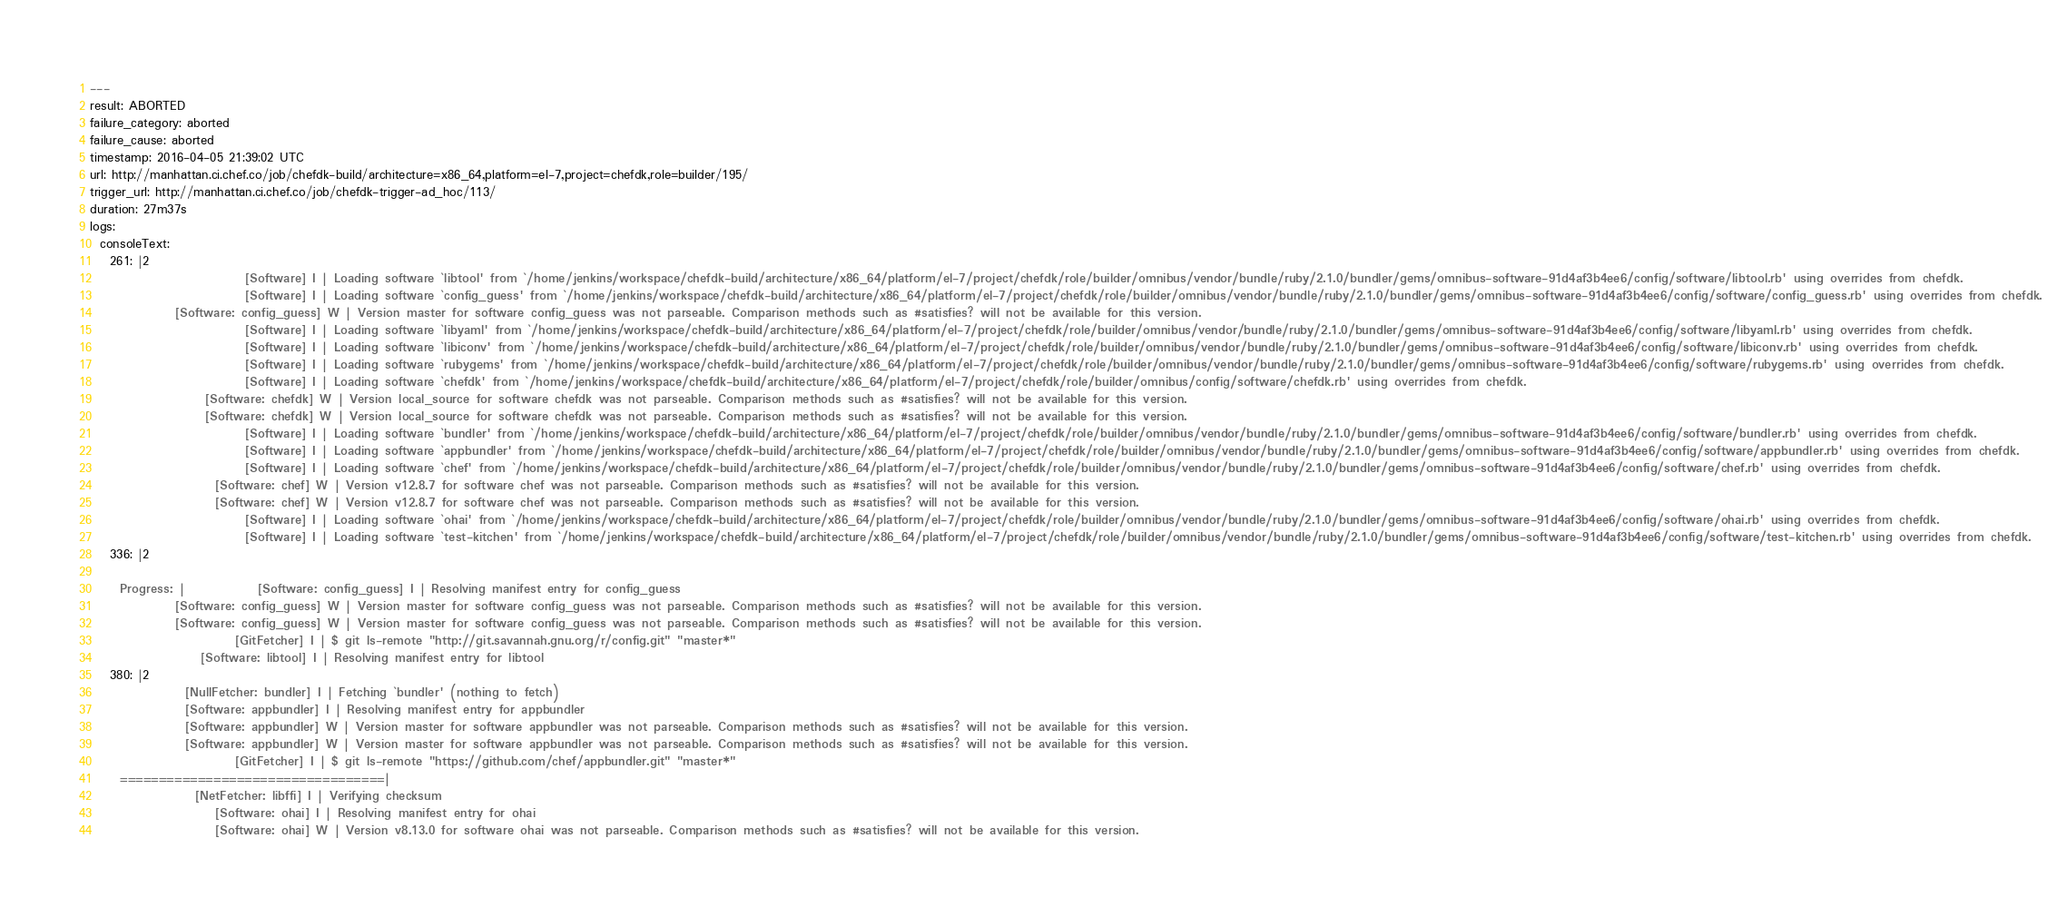<code> <loc_0><loc_0><loc_500><loc_500><_YAML_>---
result: ABORTED
failure_category: aborted
failure_cause: aborted
timestamp: 2016-04-05 21:39:02 UTC
url: http://manhattan.ci.chef.co/job/chefdk-build/architecture=x86_64,platform=el-7,project=chefdk,role=builder/195/
trigger_url: http://manhattan.ci.chef.co/job/chefdk-trigger-ad_hoc/113/
duration: 27m37s
logs:
  consoleText:
    261: |2
                               [Software] I | Loading software `libtool' from `/home/jenkins/workspace/chefdk-build/architecture/x86_64/platform/el-7/project/chefdk/role/builder/omnibus/vendor/bundle/ruby/2.1.0/bundler/gems/omnibus-software-91d4af3b4ee6/config/software/libtool.rb' using overrides from chefdk.
                               [Software] I | Loading software `config_guess' from `/home/jenkins/workspace/chefdk-build/architecture/x86_64/platform/el-7/project/chefdk/role/builder/omnibus/vendor/bundle/ruby/2.1.0/bundler/gems/omnibus-software-91d4af3b4ee6/config/software/config_guess.rb' using overrides from chefdk.
                 [Software: config_guess] W | Version master for software config_guess was not parseable. Comparison methods such as #satisfies? will not be available for this version.
                               [Software] I | Loading software `libyaml' from `/home/jenkins/workspace/chefdk-build/architecture/x86_64/platform/el-7/project/chefdk/role/builder/omnibus/vendor/bundle/ruby/2.1.0/bundler/gems/omnibus-software-91d4af3b4ee6/config/software/libyaml.rb' using overrides from chefdk.
                               [Software] I | Loading software `libiconv' from `/home/jenkins/workspace/chefdk-build/architecture/x86_64/platform/el-7/project/chefdk/role/builder/omnibus/vendor/bundle/ruby/2.1.0/bundler/gems/omnibus-software-91d4af3b4ee6/config/software/libiconv.rb' using overrides from chefdk.
                               [Software] I | Loading software `rubygems' from `/home/jenkins/workspace/chefdk-build/architecture/x86_64/platform/el-7/project/chefdk/role/builder/omnibus/vendor/bundle/ruby/2.1.0/bundler/gems/omnibus-software-91d4af3b4ee6/config/software/rubygems.rb' using overrides from chefdk.
                               [Software] I | Loading software `chefdk' from `/home/jenkins/workspace/chefdk-build/architecture/x86_64/platform/el-7/project/chefdk/role/builder/omnibus/config/software/chefdk.rb' using overrides from chefdk.
                       [Software: chefdk] W | Version local_source for software chefdk was not parseable. Comparison methods such as #satisfies? will not be available for this version.
                       [Software: chefdk] W | Version local_source for software chefdk was not parseable. Comparison methods such as #satisfies? will not be available for this version.
                               [Software] I | Loading software `bundler' from `/home/jenkins/workspace/chefdk-build/architecture/x86_64/platform/el-7/project/chefdk/role/builder/omnibus/vendor/bundle/ruby/2.1.0/bundler/gems/omnibus-software-91d4af3b4ee6/config/software/bundler.rb' using overrides from chefdk.
                               [Software] I | Loading software `appbundler' from `/home/jenkins/workspace/chefdk-build/architecture/x86_64/platform/el-7/project/chefdk/role/builder/omnibus/vendor/bundle/ruby/2.1.0/bundler/gems/omnibus-software-91d4af3b4ee6/config/software/appbundler.rb' using overrides from chefdk.
                               [Software] I | Loading software `chef' from `/home/jenkins/workspace/chefdk-build/architecture/x86_64/platform/el-7/project/chefdk/role/builder/omnibus/vendor/bundle/ruby/2.1.0/bundler/gems/omnibus-software-91d4af3b4ee6/config/software/chef.rb' using overrides from chefdk.
                         [Software: chef] W | Version v12.8.7 for software chef was not parseable. Comparison methods such as #satisfies? will not be available for this version.
                         [Software: chef] W | Version v12.8.7 for software chef was not parseable. Comparison methods such as #satisfies? will not be available for this version.
                               [Software] I | Loading software `ohai' from `/home/jenkins/workspace/chefdk-build/architecture/x86_64/platform/el-7/project/chefdk/role/builder/omnibus/vendor/bundle/ruby/2.1.0/bundler/gems/omnibus-software-91d4af3b4ee6/config/software/ohai.rb' using overrides from chefdk.
                               [Software] I | Loading software `test-kitchen' from `/home/jenkins/workspace/chefdk-build/architecture/x86_64/platform/el-7/project/chefdk/role/builder/omnibus/vendor/bundle/ruby/2.1.0/bundler/gems/omnibus-software-91d4af3b4ee6/config/software/test-kitchen.rb' using overrides from chefdk.
    336: |2

      Progress: |           [Software: config_guess] I | Resolving manifest entry for config_guess
                 [Software: config_guess] W | Version master for software config_guess was not parseable. Comparison methods such as #satisfies? will not be available for this version.
                 [Software: config_guess] W | Version master for software config_guess was not parseable. Comparison methods such as #satisfies? will not be available for this version.
                             [GitFetcher] I | $ git ls-remote "http://git.savannah.gnu.org/r/config.git" "master*"
                      [Software: libtool] I | Resolving manifest entry for libtool
    380: |2
                   [NullFetcher: bundler] I | Fetching `bundler' (nothing to fetch)
                   [Software: appbundler] I | Resolving manifest entry for appbundler
                   [Software: appbundler] W | Version master for software appbundler was not parseable. Comparison methods such as #satisfies? will not be available for this version.
                   [Software: appbundler] W | Version master for software appbundler was not parseable. Comparison methods such as #satisfies? will not be available for this version.
                             [GitFetcher] I | $ git ls-remote "https://github.com/chef/appbundler.git" "master*"
      ==================================|
                     [NetFetcher: libffi] I | Verifying checksum
                         [Software: ohai] I | Resolving manifest entry for ohai
                         [Software: ohai] W | Version v8.13.0 for software ohai was not parseable. Comparison methods such as #satisfies? will not be available for this version.</code> 